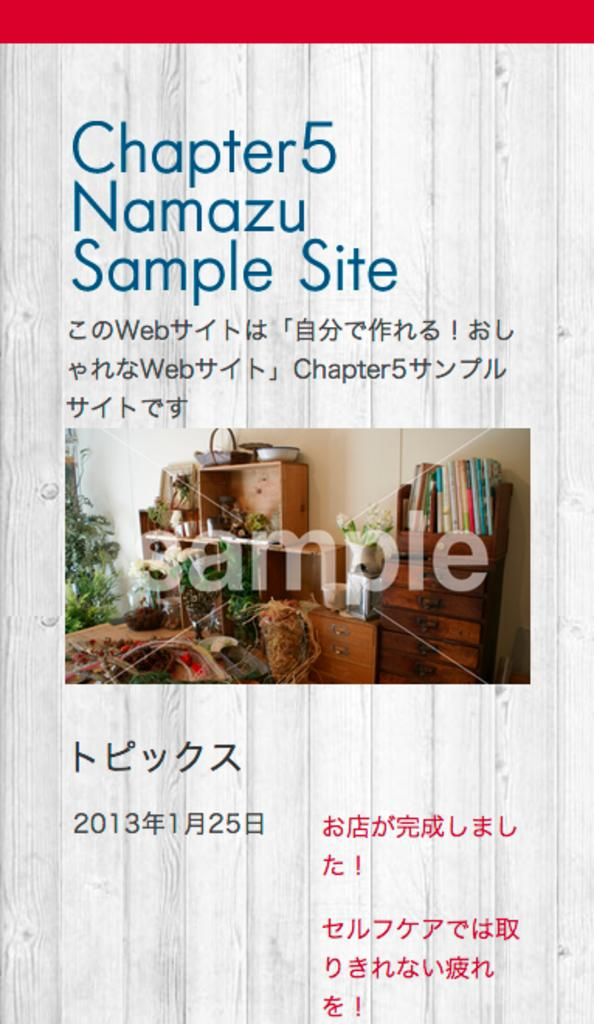<image>
Present a compact description of the photo's key features. A sample site that has an image of furniture with the word sample on it. 